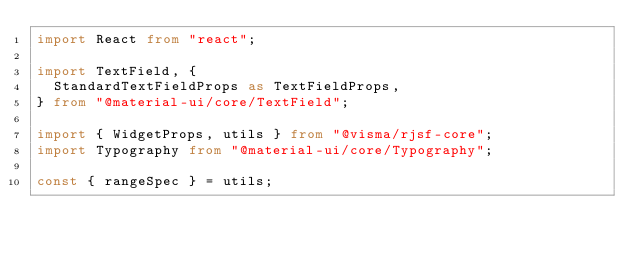<code> <loc_0><loc_0><loc_500><loc_500><_TypeScript_>import React from "react";

import TextField, {
  StandardTextFieldProps as TextFieldProps,
} from "@material-ui/core/TextField";

import { WidgetProps, utils } from "@visma/rjsf-core";
import Typography from "@material-ui/core/Typography";

const { rangeSpec } = utils;
</code> 